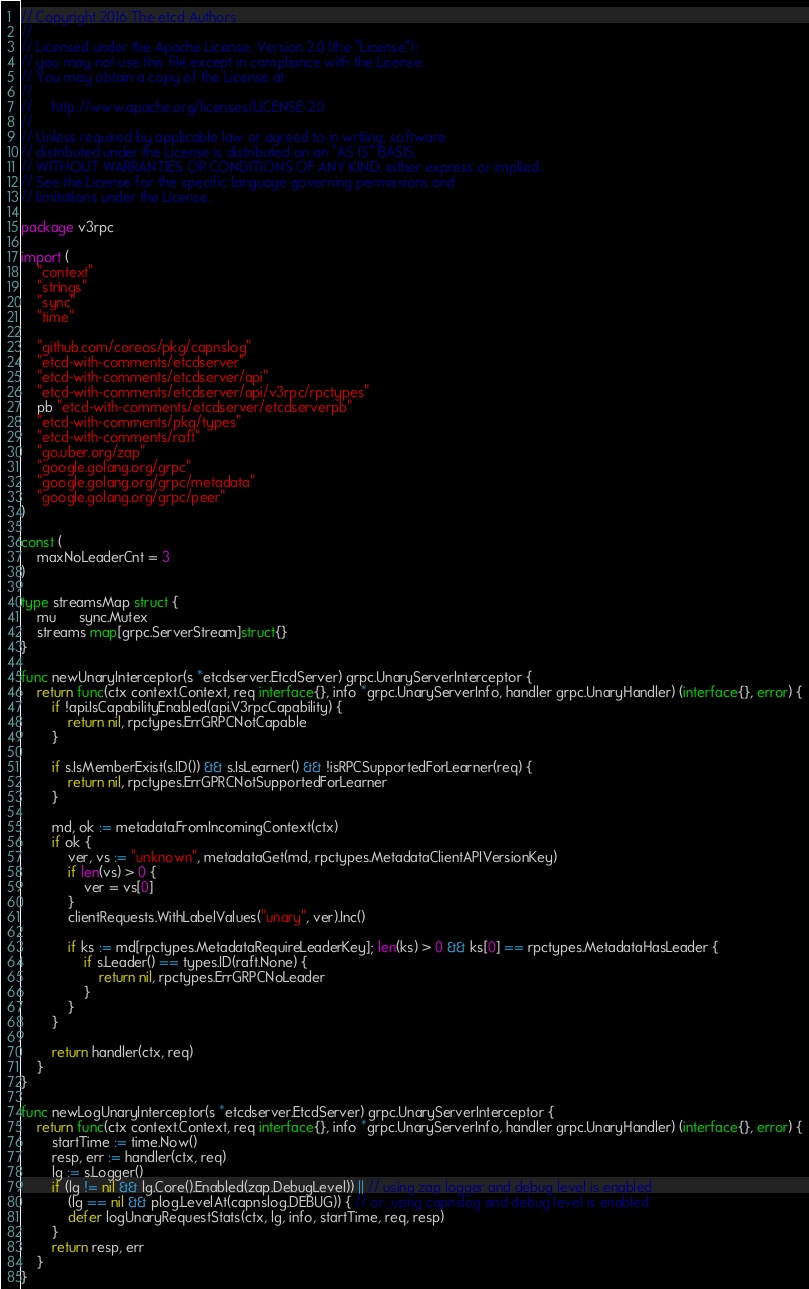Convert code to text. <code><loc_0><loc_0><loc_500><loc_500><_Go_>// Copyright 2016 The etcd Authors
//
// Licensed under the Apache License, Version 2.0 (the "License");
// you may not use this file except in compliance with the License.
// You may obtain a copy of the License at
//
//     http://www.apache.org/licenses/LICENSE-2.0
//
// Unless required by applicable law or agreed to in writing, software
// distributed under the License is distributed on an "AS IS" BASIS,
// WITHOUT WARRANTIES OR CONDITIONS OF ANY KIND, either express or implied.
// See the License for the specific language governing permissions and
// limitations under the License.

package v3rpc

import (
	"context"
	"strings"
	"sync"
	"time"

	"github.com/coreos/pkg/capnslog"
	"etcd-with-comments/etcdserver"
	"etcd-with-comments/etcdserver/api"
	"etcd-with-comments/etcdserver/api/v3rpc/rpctypes"
	pb "etcd-with-comments/etcdserver/etcdserverpb"
	"etcd-with-comments/pkg/types"
	"etcd-with-comments/raft"
	"go.uber.org/zap"
	"google.golang.org/grpc"
	"google.golang.org/grpc/metadata"
	"google.golang.org/grpc/peer"
)

const (
	maxNoLeaderCnt = 3
)

type streamsMap struct {
	mu      sync.Mutex
	streams map[grpc.ServerStream]struct{}
}

func newUnaryInterceptor(s *etcdserver.EtcdServer) grpc.UnaryServerInterceptor {
	return func(ctx context.Context, req interface{}, info *grpc.UnaryServerInfo, handler grpc.UnaryHandler) (interface{}, error) {
		if !api.IsCapabilityEnabled(api.V3rpcCapability) {
			return nil, rpctypes.ErrGRPCNotCapable
		}

		if s.IsMemberExist(s.ID()) && s.IsLearner() && !isRPCSupportedForLearner(req) {
			return nil, rpctypes.ErrGPRCNotSupportedForLearner
		}

		md, ok := metadata.FromIncomingContext(ctx)
		if ok {
			ver, vs := "unknown", metadataGet(md, rpctypes.MetadataClientAPIVersionKey)
			if len(vs) > 0 {
				ver = vs[0]
			}
			clientRequests.WithLabelValues("unary", ver).Inc()

			if ks := md[rpctypes.MetadataRequireLeaderKey]; len(ks) > 0 && ks[0] == rpctypes.MetadataHasLeader {
				if s.Leader() == types.ID(raft.None) {
					return nil, rpctypes.ErrGRPCNoLeader
				}
			}
		}

		return handler(ctx, req)
	}
}

func newLogUnaryInterceptor(s *etcdserver.EtcdServer) grpc.UnaryServerInterceptor {
	return func(ctx context.Context, req interface{}, info *grpc.UnaryServerInfo, handler grpc.UnaryHandler) (interface{}, error) {
		startTime := time.Now()
		resp, err := handler(ctx, req)
		lg := s.Logger()
		if (lg != nil && lg.Core().Enabled(zap.DebugLevel)) || // using zap logger and debug level is enabled
			(lg == nil && plog.LevelAt(capnslog.DEBUG)) { // or, using capnslog and debug level is enabled
			defer logUnaryRequestStats(ctx, lg, info, startTime, req, resp)
		}
		return resp, err
	}
}
</code> 